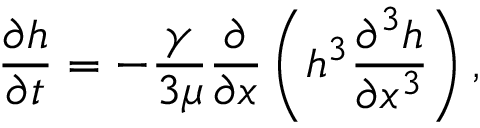<formula> <loc_0><loc_0><loc_500><loc_500>\frac { \partial h } { \partial t } = - \frac { \gamma } { 3 \mu } \frac { \partial } { \partial x } \left ( h ^ { 3 } \frac { \partial ^ { 3 } h } { \partial x ^ { 3 } } \right ) ,</formula> 